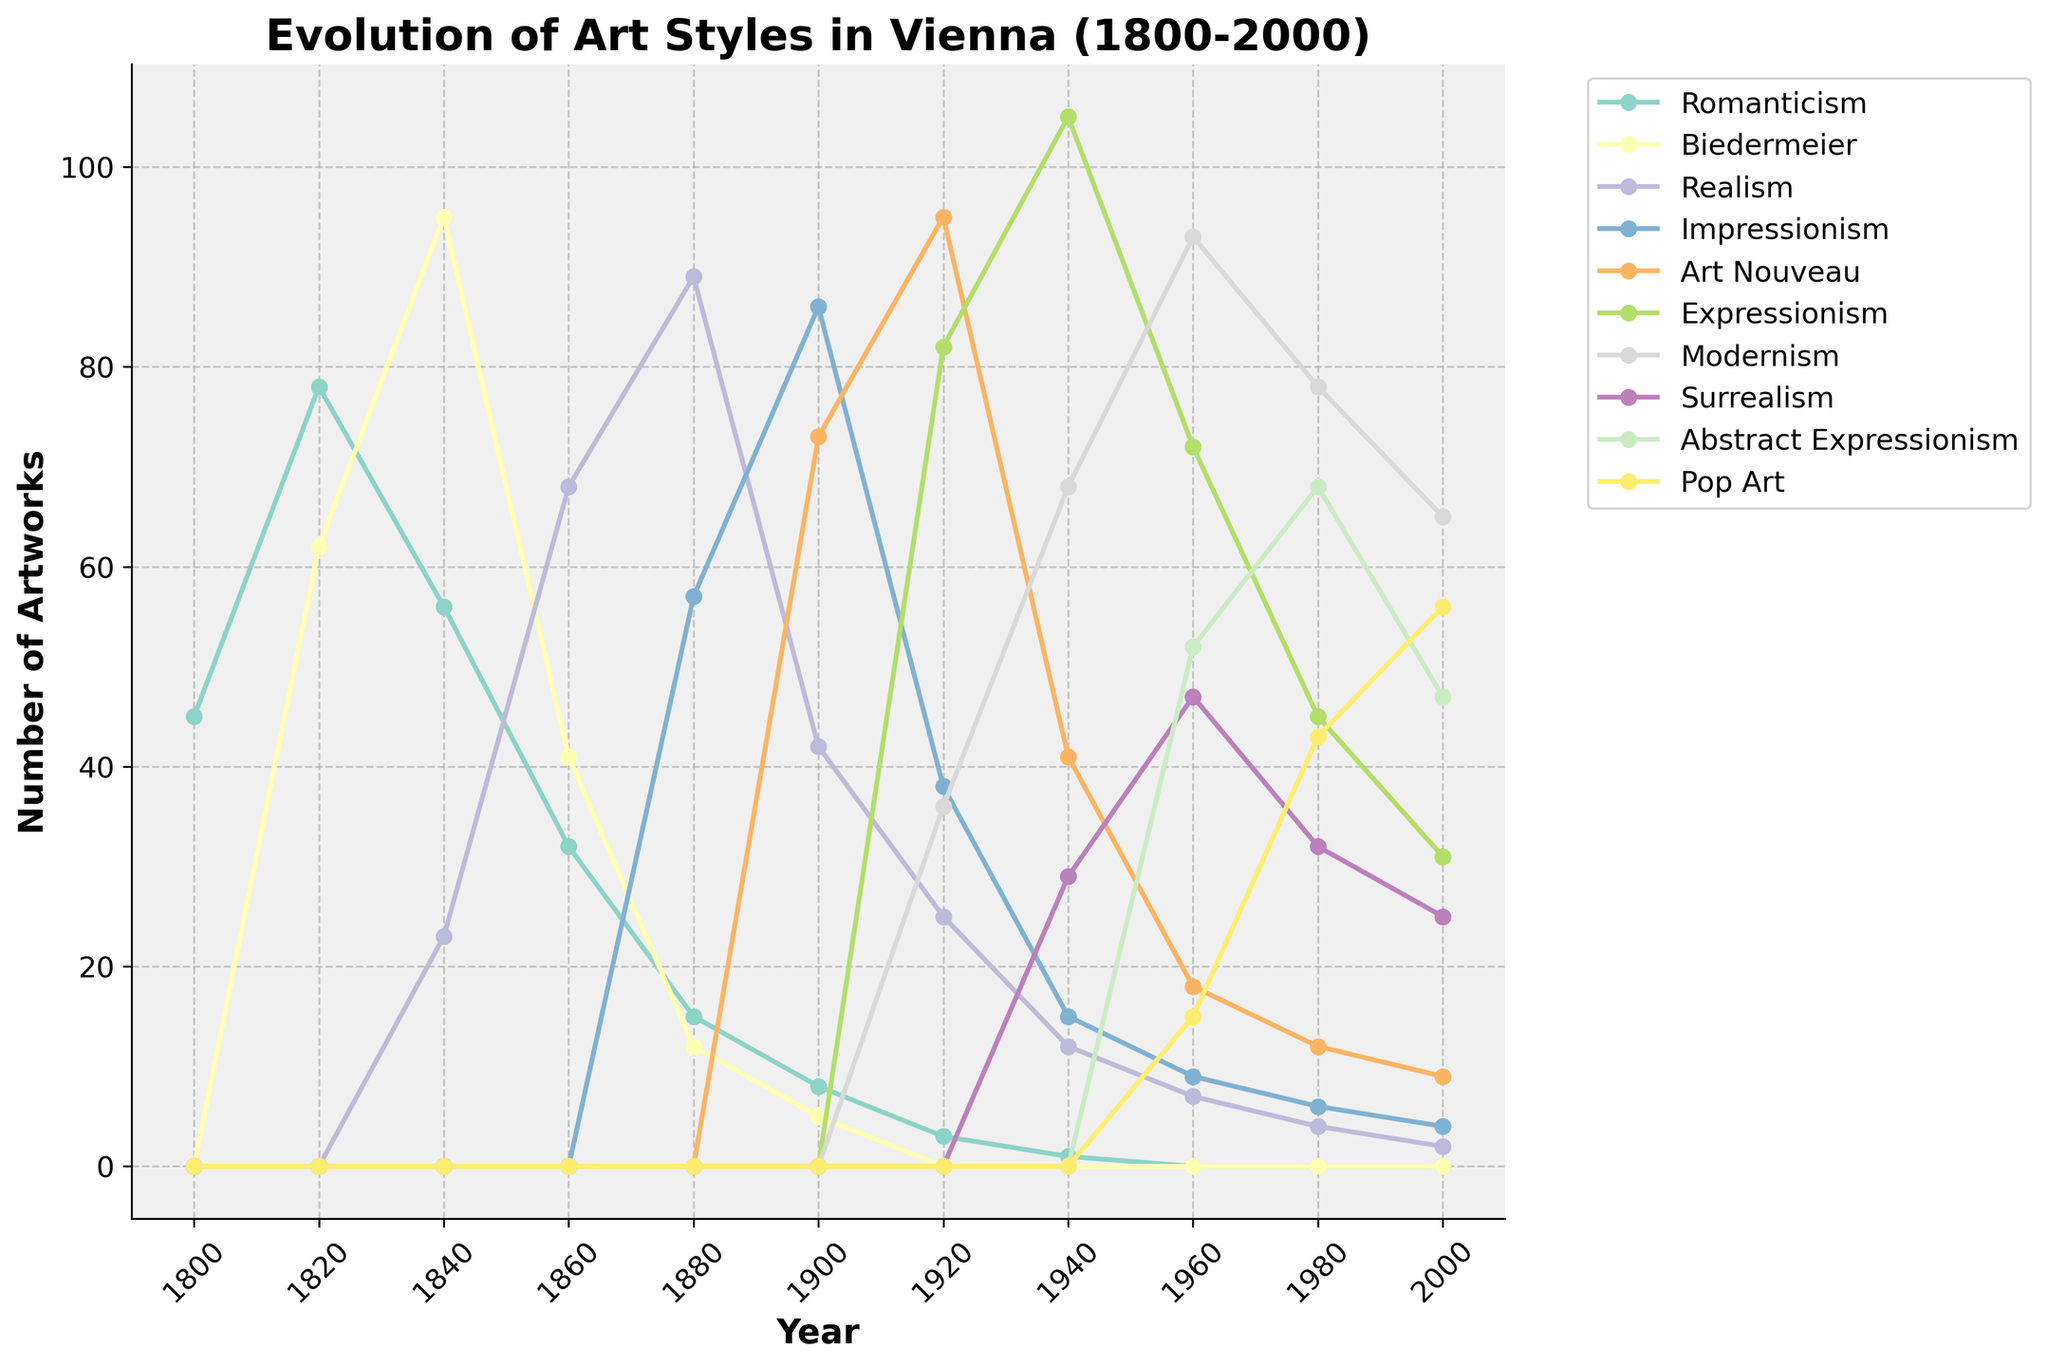What art style experienced the highest number of artworks in 1920? From the figure, look for the peak value among all art styles in the year 1920. The color corresponding to Expressionism shows the highest point at 95 artworks.
Answer: Expressionism Between which consecutive decades did Impressionism see its greatest decline? Examine the trend of the Impressionism line. The biggest drop occurs between 1900 (86) and 1920 (38). Calculate this difference, 86 - 38 = 48.
Answer: 1900 to 1920 What was the combined number of artworks for Modernism and Surrealism in 1960? Refer to the data points for Modernism (93) and Surrealism (47) in 1960. Sum these values: 93 + 47 = 140.
Answer: 140 In which decade did Romanticism drop to less than 10 artworks? Follow the trend of the Romanticism line and find the decade where it falls below 10 artworks. This occurs in the 1900s where it drops to 8.
Answer: 1900 Which art style shows a continuous rise from 1920 to 1960? Look at each line for the period from 1920 to 1960. Pop Art increases from 0 in 1920 to 15 in 1960.
Answer: Pop Art What is the difference in the number of Realism artworks between 1880 and 1940? Find the number of artworks for Realism in 1880 (89) and 1940 (12). Calculate the difference: 89 - 12 = 77.
Answer: 77 Between Art Nouveau and Expressionism in 1940, which art style had more artworks and by how much? Look at 1940 data points for both Art Nouveau (41) and Expressionism (105). Calculate the difference: 105 - 41 = 64.
Answer: Expressionism by 64 What is the average number of artworks for Romanticism between 1800 and 2000? Add the data points for Romanticism from each decade (45, 78, 56, 32, 15, 8, 3, 1, 0, 0, 0). Sum = 238. Calculate the average: 238 / 11 = 21.64 (rounded to 2 decimal places).
Answer: 21.64 Which decade marks the first appearance of Abstract Expressionism in Vienna? Trace the line for Abstract Expressionism and find its first non-zero data point, which is in 1960 with 52 artworks.
Answer: 1960 